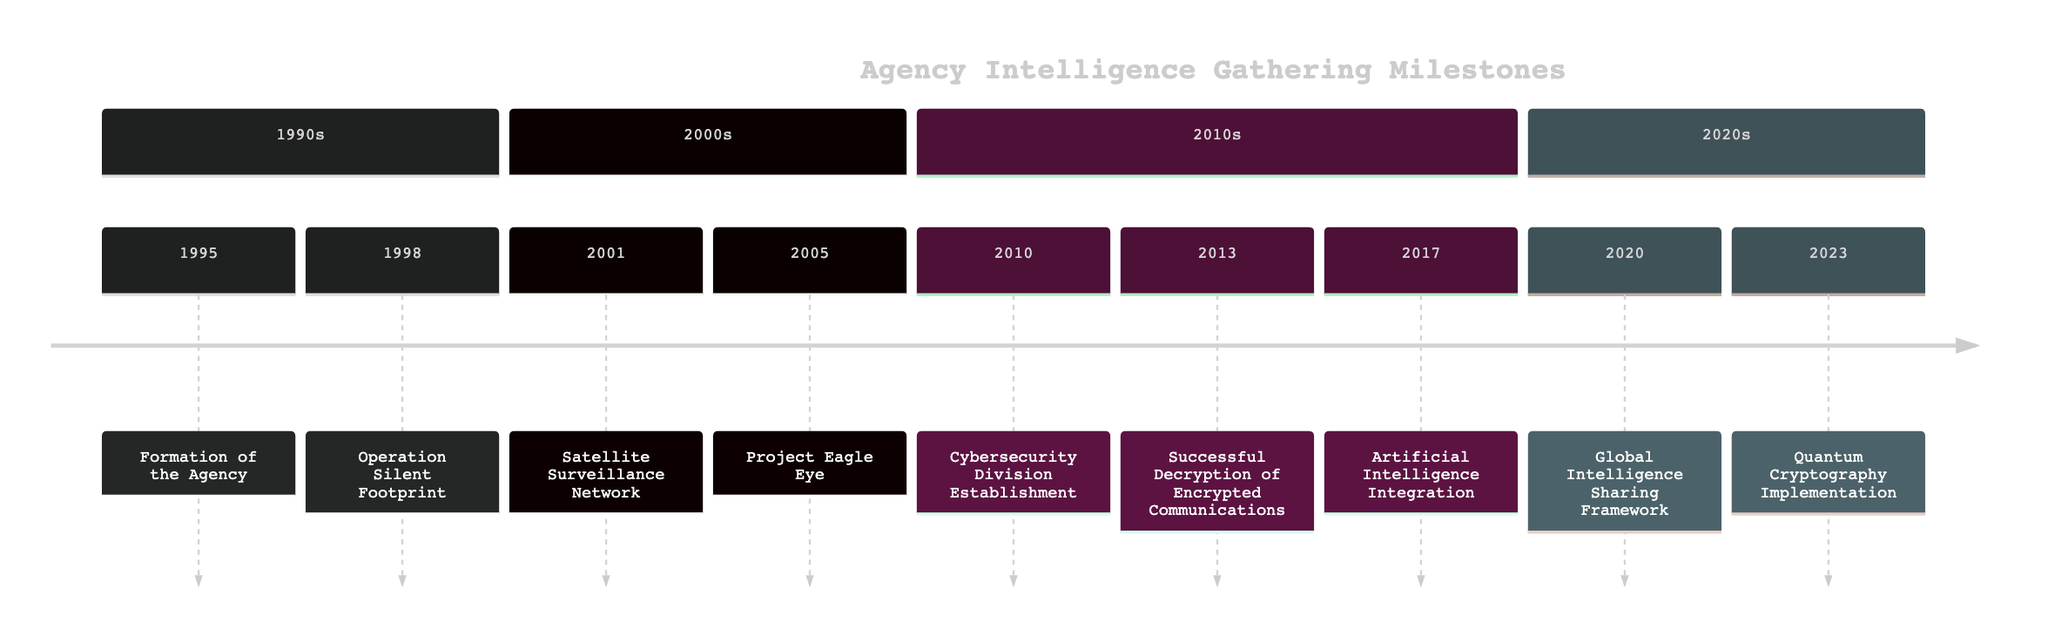What year was the Agency formed? The diagram indicates that the Agency was formed in 1995.
Answer: 1995 What event occurred in 2010? By looking at the timeline, the event in 2010 is the establishment of the Cybersecurity Division.
Answer: Cybersecurity Division Establishment Which operation was pivotal in 1998? The operation listed for 1998 is Operation Silent Footprint, which was pivotal in uncovering a cyber-espionage network.
Answer: Operation Silent Footprint How many events are listed in the 2010s section? In the 2010s section, there are three events: Cybersecurity Division Establishment, Successful Decryption of Encrypted Communications, and Artificial Intelligence Integration. Thus, the count is three.
Answer: 3 What technology was implemented in 2023? The diagram specifies that Quantum Cryptography was implemented in 2023.
Answer: Quantum Cryptography Implementation Which event marks the introduction of drone technologies? The introduction of drone technologies is marked by Project Eagle Eye in 2005.
Answer: Project Eagle Eye How did the Agency address cybersecurity threats? The Agency addressed cybersecurity threats by establishing a specialized division in 2010, as shown in the timeline.
Answer: Cybersecurity Division Establishment What is the relationship between Operation Silent Footprint and the Satellite Surveillance Network? Operation Silent Footprint in 1998 precedes the Satellite Surveillance Network in 2001, indicating a timeline of events focused on security threats.
Answer: Preceding Which year saw the deployment of AI algorithms for threat analysis? The deployment of AI algorithms occurred in 2017, as noted in the timeline.
Answer: 2017 